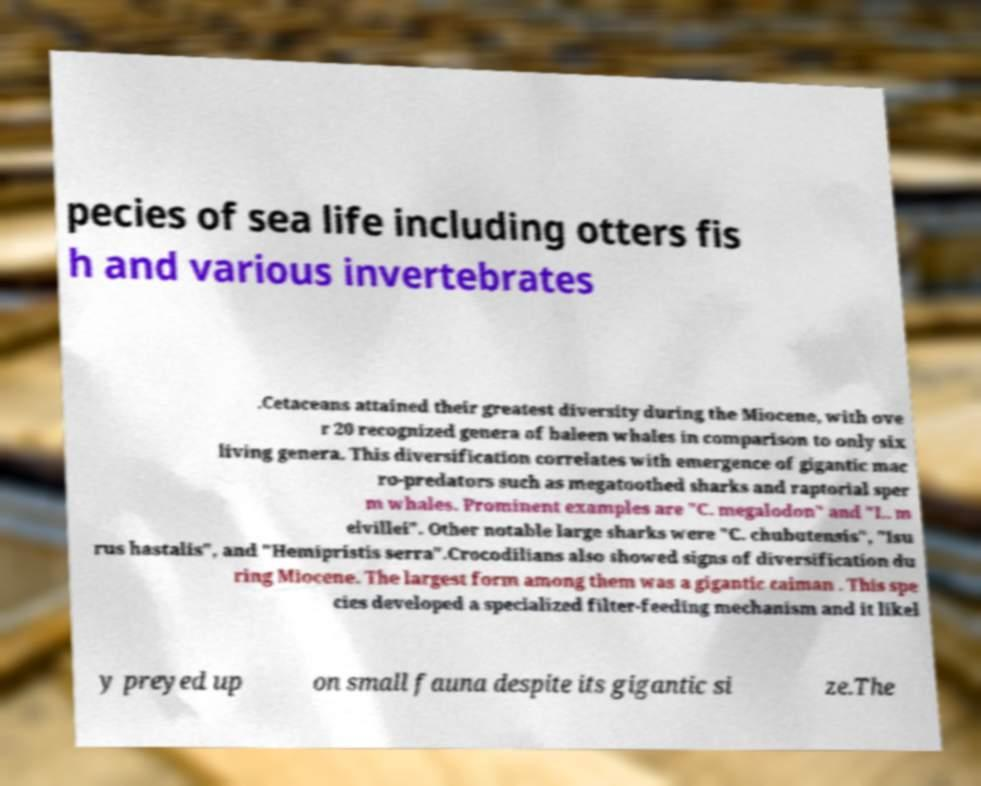Can you read and provide the text displayed in the image?This photo seems to have some interesting text. Can you extract and type it out for me? pecies of sea life including otters fis h and various invertebrates .Cetaceans attained their greatest diversity during the Miocene, with ove r 20 recognized genera of baleen whales in comparison to only six living genera. This diversification correlates with emergence of gigantic mac ro-predators such as megatoothed sharks and raptorial sper m whales. Prominent examples are "C. megalodon" and "L. m elvillei". Other notable large sharks were "C. chubutensis", "Isu rus hastalis", and "Hemipristis serra".Crocodilians also showed signs of diversification du ring Miocene. The largest form among them was a gigantic caiman . This spe cies developed a specialized filter-feeding mechanism and it likel y preyed up on small fauna despite its gigantic si ze.The 